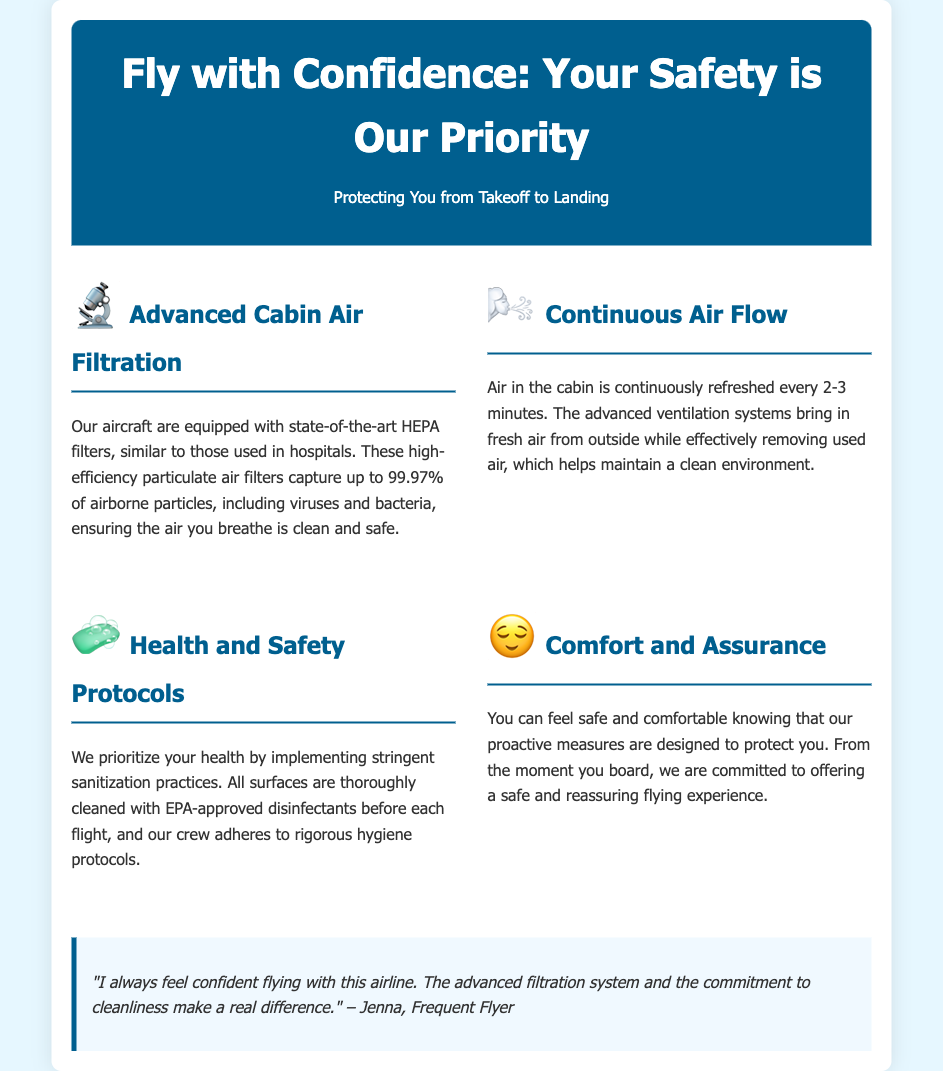What type of air filters do the aircraft use? The document states that the aircraft are equipped with HEPA filters, which are high-efficiency particulate air filters.
Answer: HEPA filters How often is the cabin air refreshed? The document mentions that the cabin air is refreshed every 2-3 minutes.
Answer: every 2-3 minutes What percentage of airborne particles do HEPA filters capture? According to the document, HEPA filters capture up to 99.97% of airborne particles.
Answer: 99.97% What health and safety protocols are mentioned? The document specifies the implementation of stringent sanitization practices and thorough cleaning with EPA-approved disinfectants.
Answer: sanitization practices What is prioritized according to the document? The document emphasizes prioritizing your health.
Answer: health 